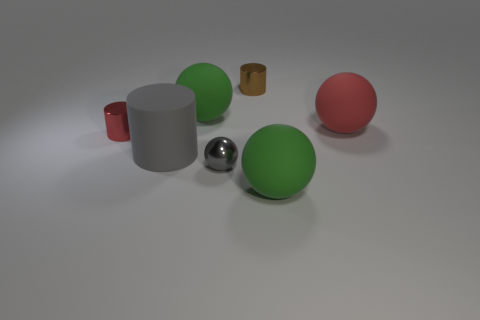There is a gray metal thing; does it have the same size as the green thing that is to the right of the tiny gray object?
Your answer should be very brief. No. What number of large things are purple balls or red shiny things?
Give a very brief answer. 0. Are there more small gray metallic spheres than tiny brown spheres?
Provide a short and direct response. Yes. How many brown metal cylinders are to the right of the big green rubber sphere on the left side of the green matte ball in front of the big red object?
Keep it short and to the point. 1. What shape is the gray metallic object?
Provide a short and direct response. Sphere. What number of other objects are there of the same material as the red cylinder?
Ensure brevity in your answer.  2. Does the shiny sphere have the same size as the brown object?
Give a very brief answer. Yes. There is a red object right of the big gray rubber cylinder; what is its shape?
Keep it short and to the point. Sphere. There is a matte thing on the right side of the big rubber sphere that is in front of the gray rubber object; what color is it?
Your answer should be very brief. Red. Is the shape of the green thing in front of the red cylinder the same as the red object to the right of the large matte cylinder?
Make the answer very short. Yes. 